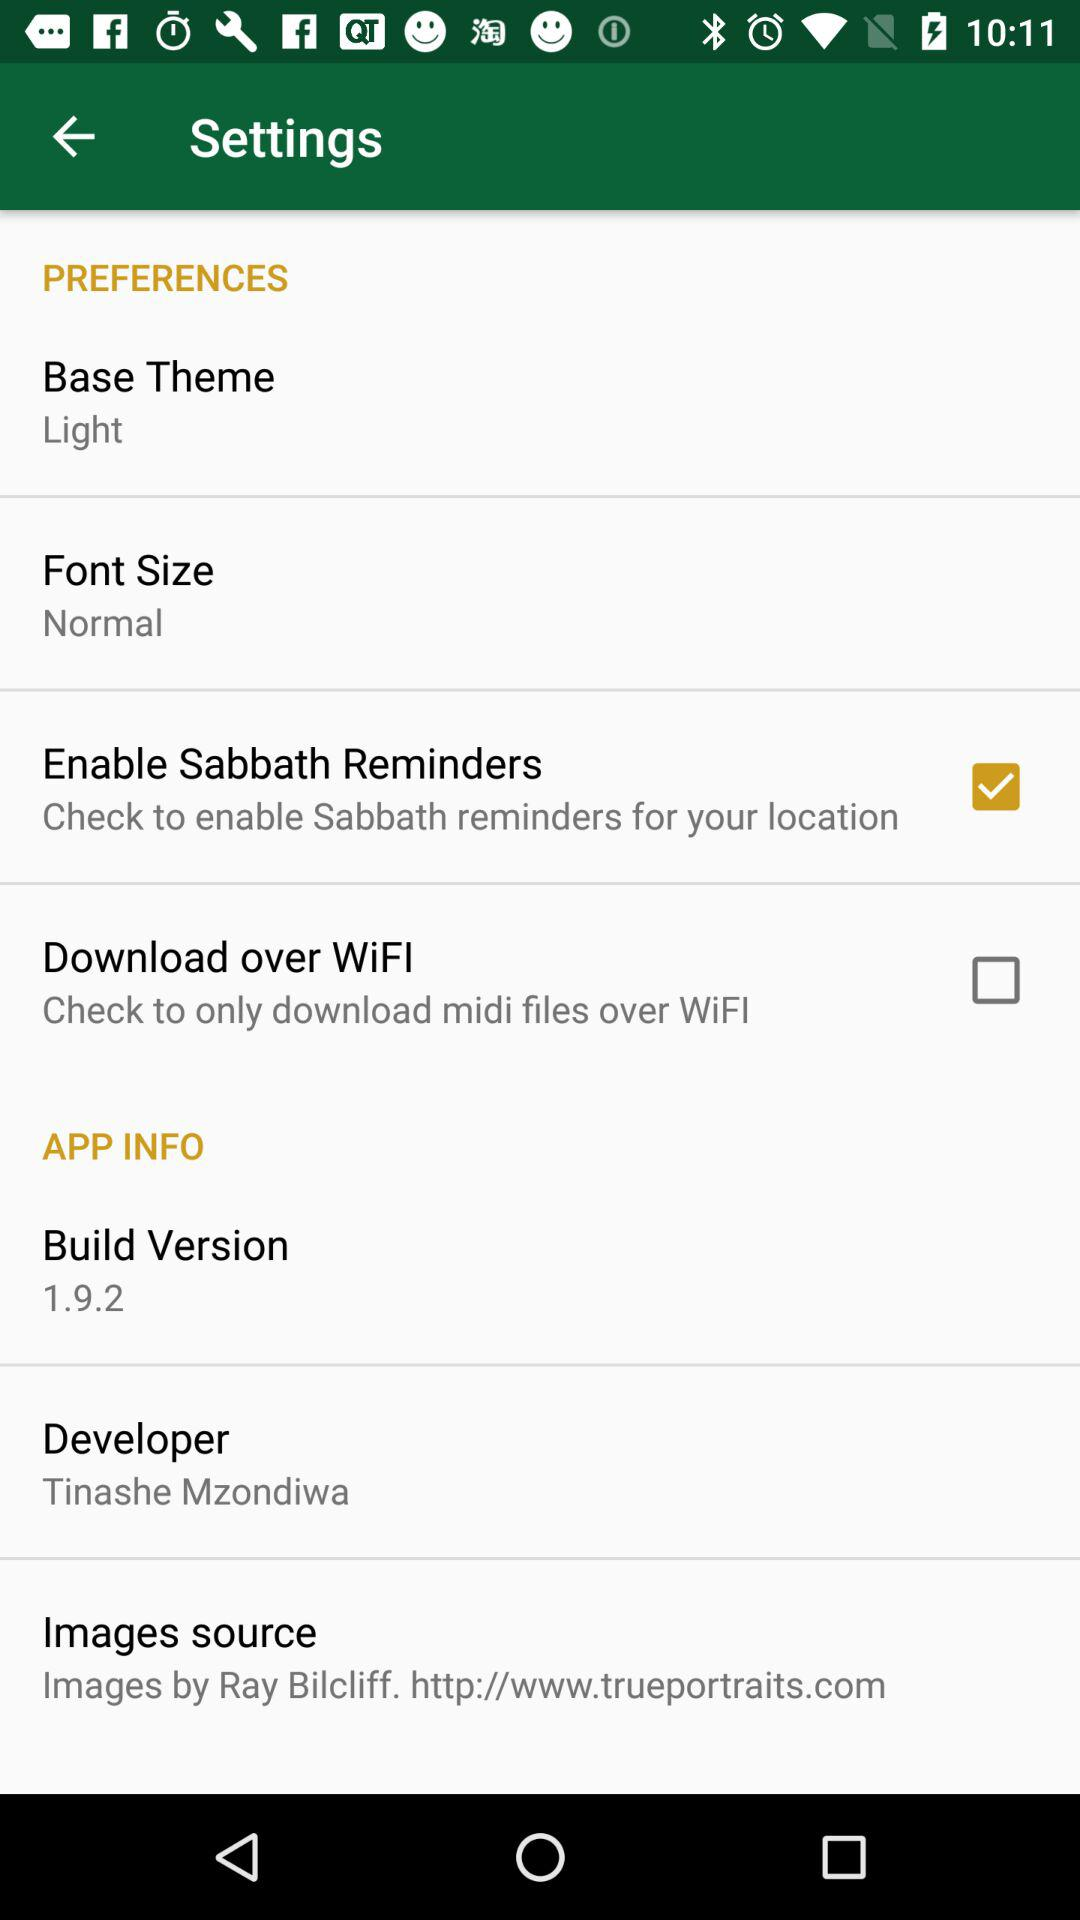What is the status of the "Enable Sabbath Reminder"? The status is "on". 